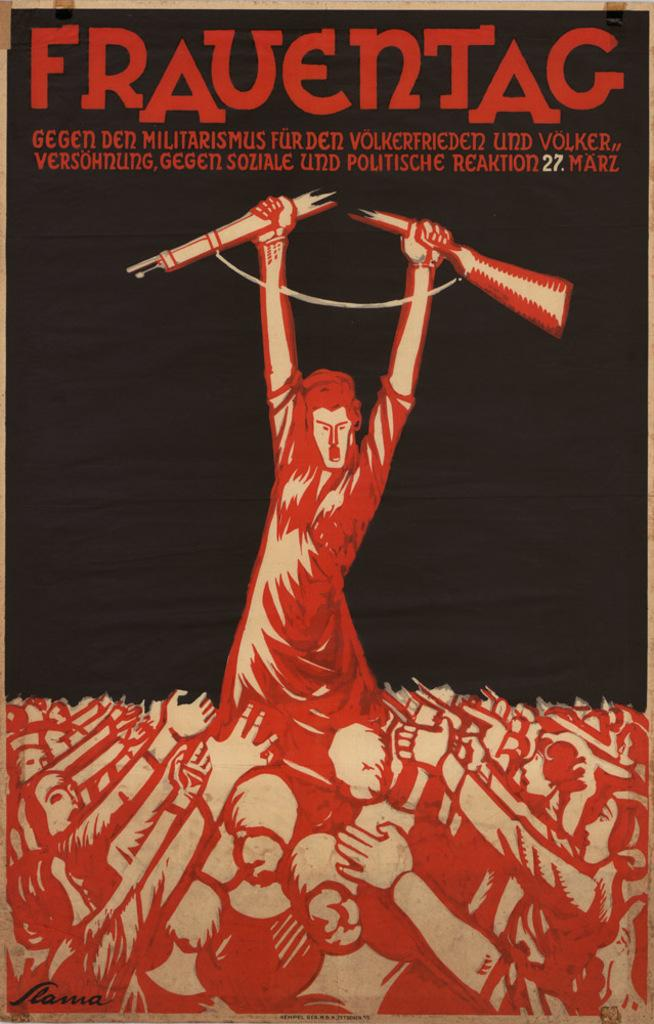<image>
Write a terse but informative summary of the picture. German political  Frauentag poster showing the leader standing tall breaking a rifle. 